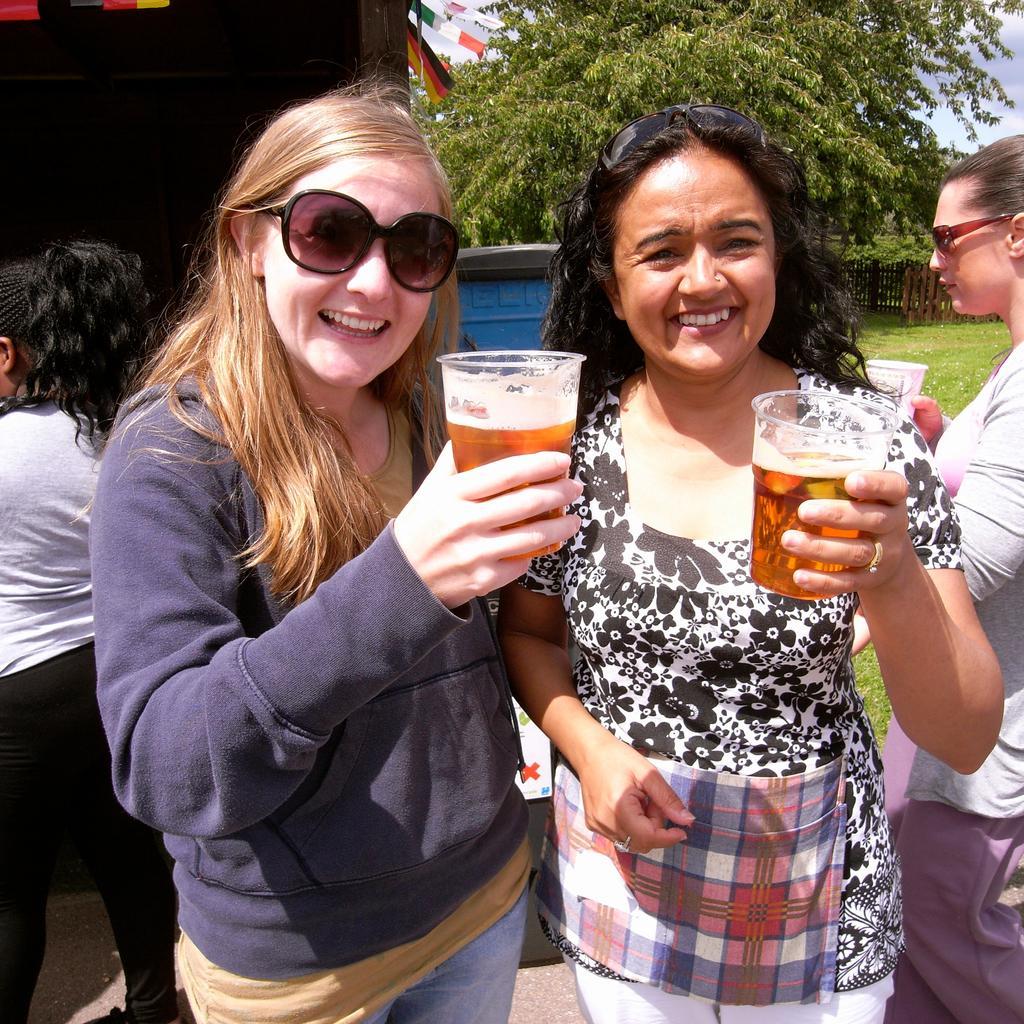Please provide a concise description of this image. In the image we can see there are people who are standing and holding wine glasses in their hand and at the back there are lot of trees. 